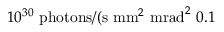Convert formula to latex. <formula><loc_0><loc_0><loc_500><loc_500>1 0 ^ { 3 0 } \ p h o t o n s / ( s \ m m ^ { 2 } \ m r a d ^ { 2 } \ 0 . 1 \</formula> 